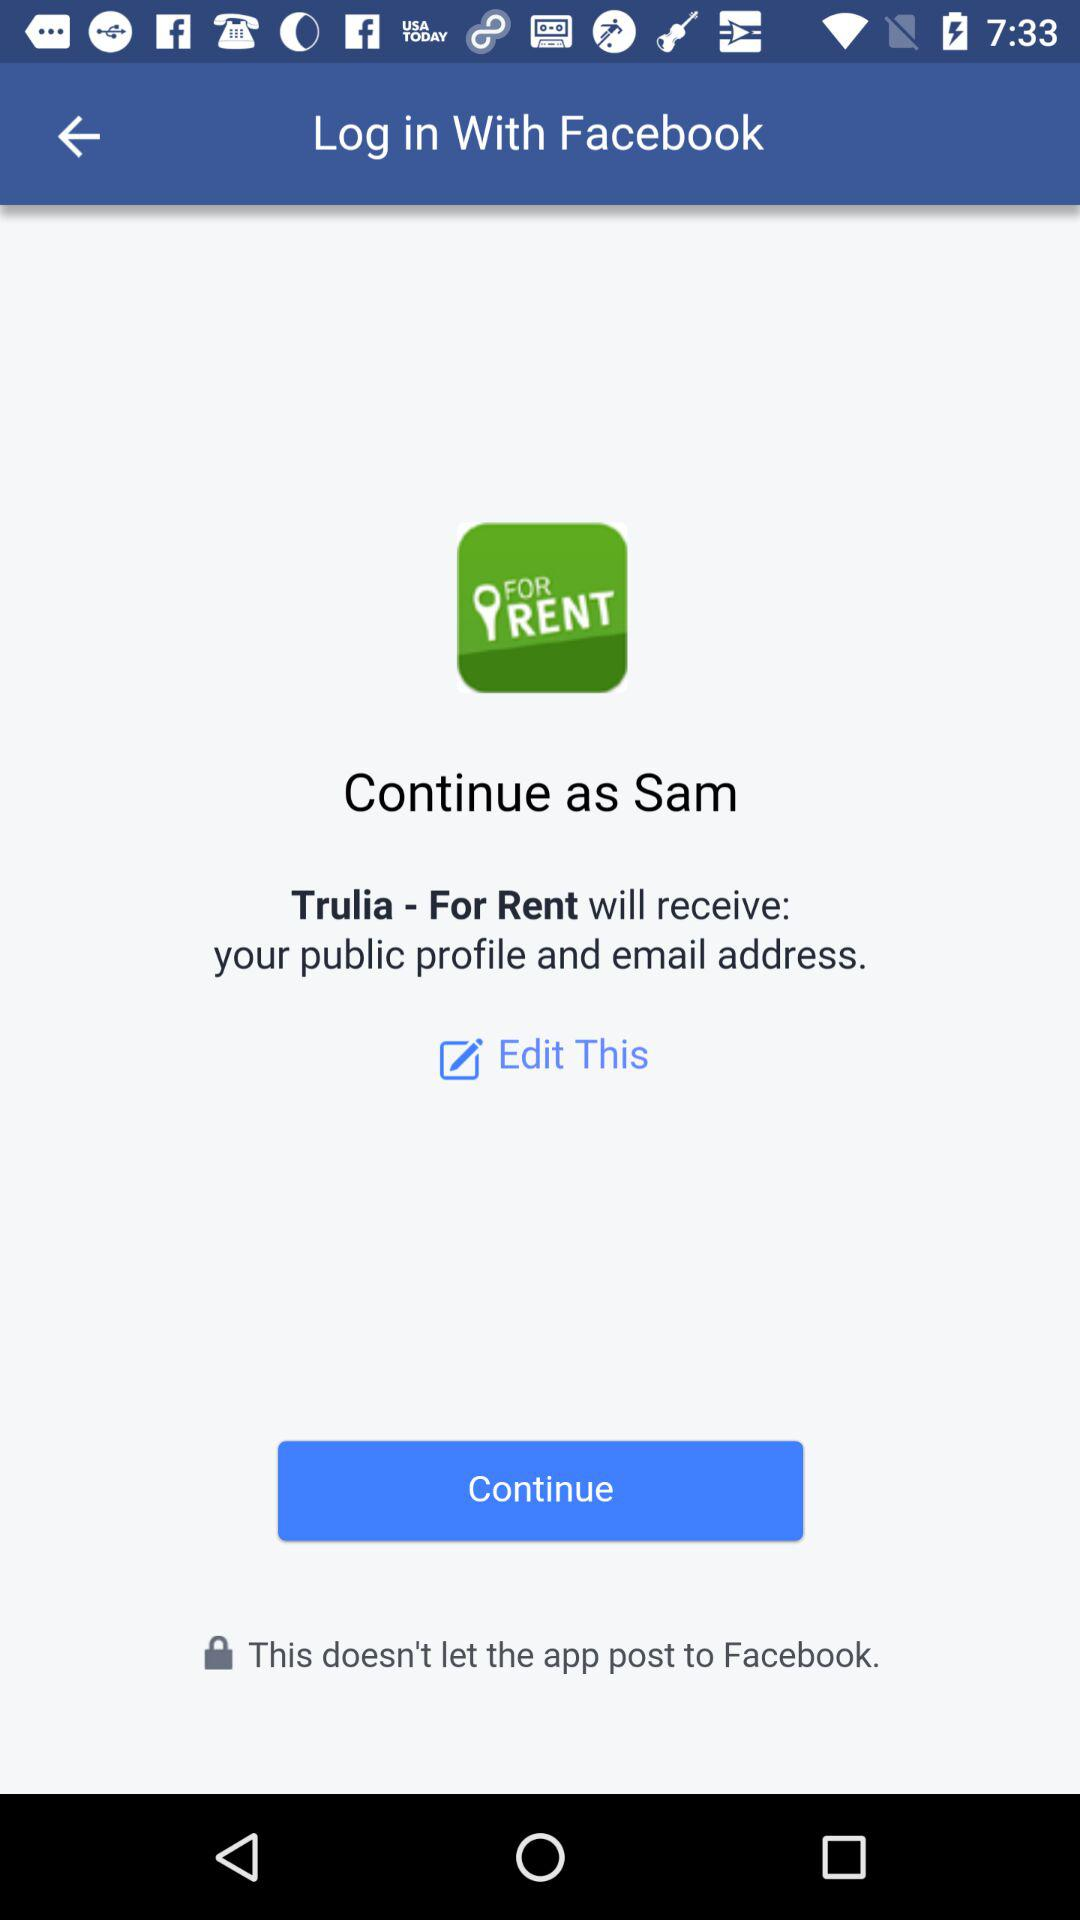What application is asking for permission? The application asking for permission is "Trulia - For Rent". 